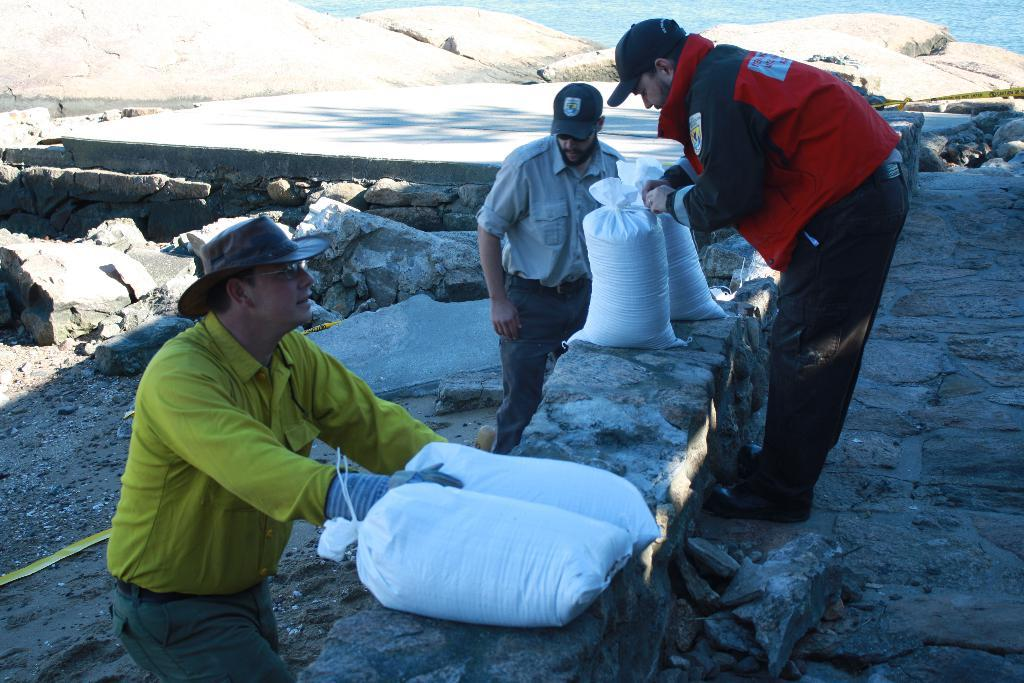How many men are present in the image? There are three men standing in the image. What color are the bags visible in the image? The bags in the image are white. What type of natural elements can be seen in the image? There are stones and rocks in the image. What is the liquid element visible in the image? There is water visible in the image. Where is the crate located in the image? There is no crate present in the image. What type of spot can be seen on the men's clothing in the image? There is no mention of spots on the men's clothing in the image. 